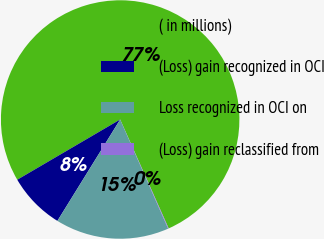Convert chart to OTSL. <chart><loc_0><loc_0><loc_500><loc_500><pie_chart><fcel>( in millions)<fcel>(Loss) gain recognized in OCI<fcel>Loss recognized in OCI on<fcel>(Loss) gain reclassified from<nl><fcel>76.76%<fcel>7.75%<fcel>15.41%<fcel>0.08%<nl></chart> 